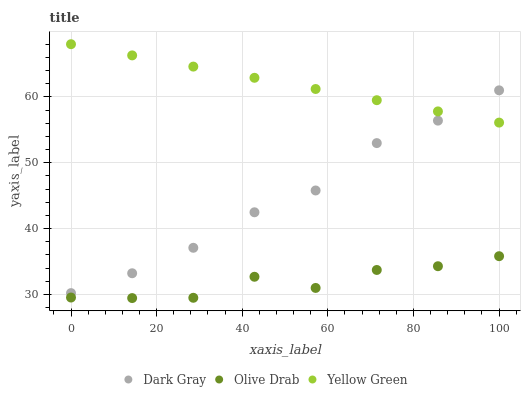Does Olive Drab have the minimum area under the curve?
Answer yes or no. Yes. Does Yellow Green have the maximum area under the curve?
Answer yes or no. Yes. Does Yellow Green have the minimum area under the curve?
Answer yes or no. No. Does Olive Drab have the maximum area under the curve?
Answer yes or no. No. Is Yellow Green the smoothest?
Answer yes or no. Yes. Is Olive Drab the roughest?
Answer yes or no. Yes. Is Olive Drab the smoothest?
Answer yes or no. No. Is Yellow Green the roughest?
Answer yes or no. No. Does Olive Drab have the lowest value?
Answer yes or no. Yes. Does Yellow Green have the lowest value?
Answer yes or no. No. Does Yellow Green have the highest value?
Answer yes or no. Yes. Does Olive Drab have the highest value?
Answer yes or no. No. Is Olive Drab less than Dark Gray?
Answer yes or no. Yes. Is Dark Gray greater than Olive Drab?
Answer yes or no. Yes. Does Yellow Green intersect Dark Gray?
Answer yes or no. Yes. Is Yellow Green less than Dark Gray?
Answer yes or no. No. Is Yellow Green greater than Dark Gray?
Answer yes or no. No. Does Olive Drab intersect Dark Gray?
Answer yes or no. No. 